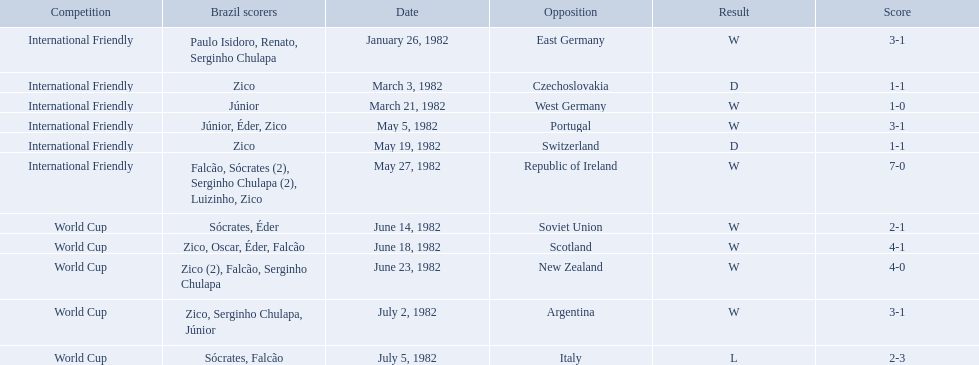How many goals did brazil score against the soviet union? 2-1. How many goals did brazil score against portugal? 3-1. Did brazil score more goals against portugal or the soviet union? Portugal. What are the dates? January 26, 1982, March 3, 1982, March 21, 1982, May 5, 1982, May 19, 1982, May 27, 1982, June 14, 1982, June 18, 1982, June 23, 1982, July 2, 1982, July 5, 1982. And which date is listed first? January 26, 1982. 